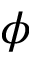<formula> <loc_0><loc_0><loc_500><loc_500>\phi</formula> 